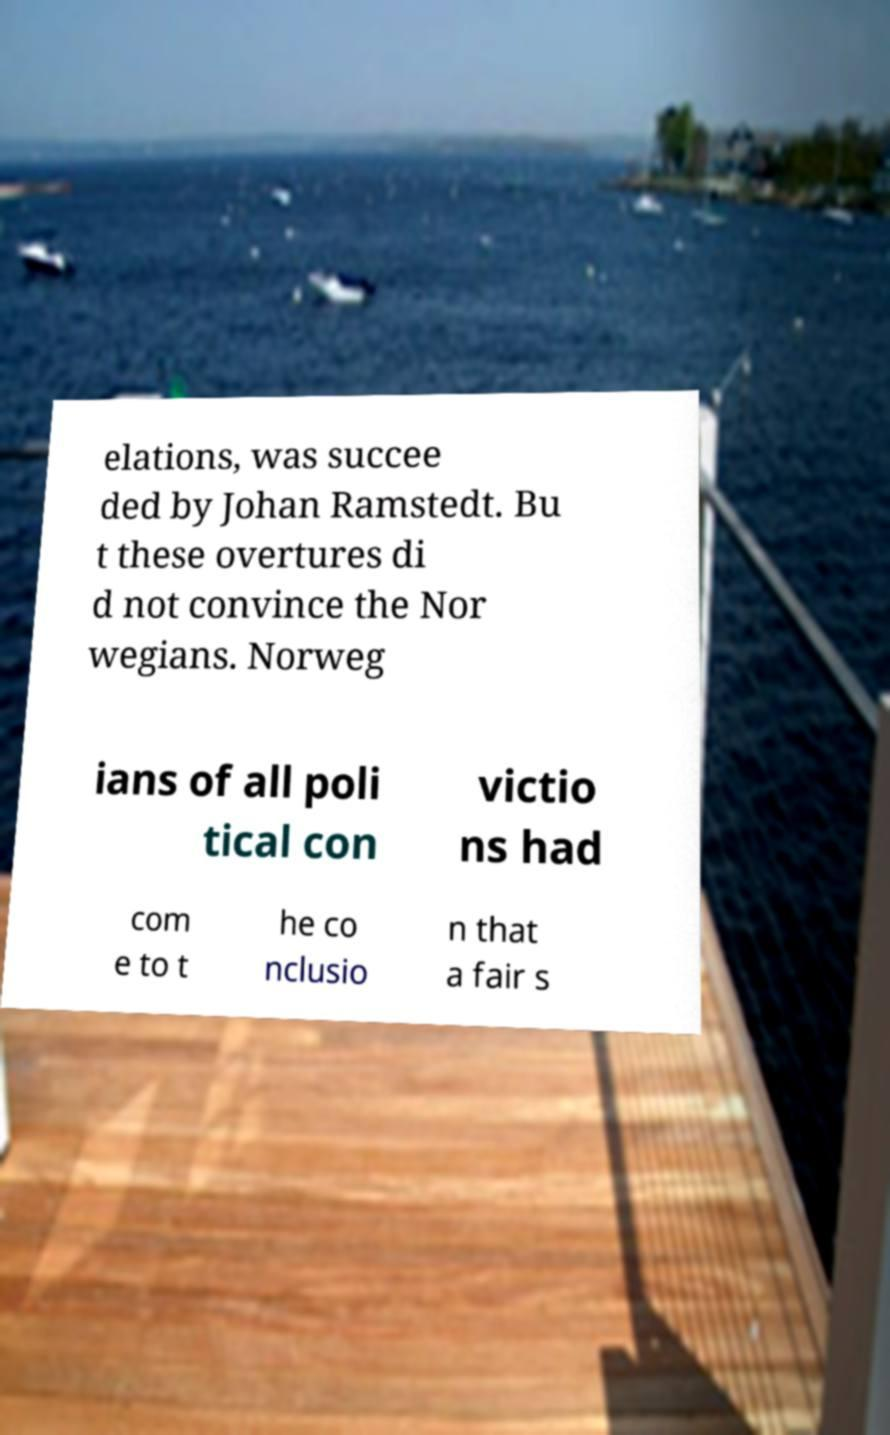Could you assist in decoding the text presented in this image and type it out clearly? elations, was succee ded by Johan Ramstedt. Bu t these overtures di d not convince the Nor wegians. Norweg ians of all poli tical con victio ns had com e to t he co nclusio n that a fair s 